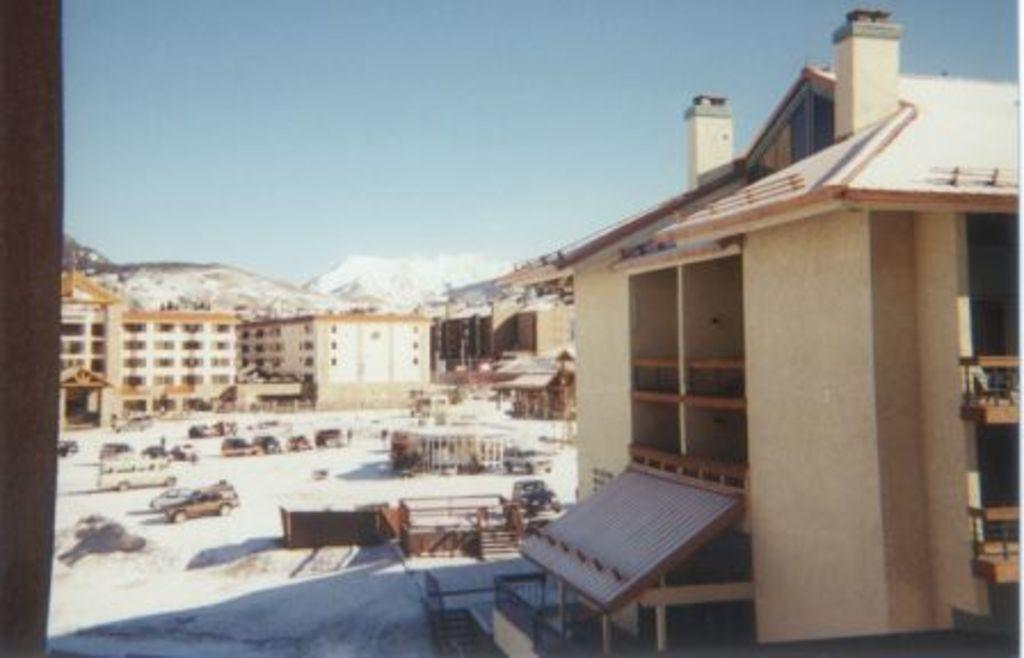What type of structures can be seen in the image? There are many buildings in the image. What natural feature is visible in the background? There are: There are mountains visible in the image. What type of transportation can be seen in the image? There are vehicles in the middle of a ground in the image. Can you describe the surroundings of the vehicles? There are other unspecified things around the vehicles in the ground. What type of note is attached to the toothpaste in the image? There is no toothpaste or note present in the image. What color is the van in the image? There is no van present in the image. 